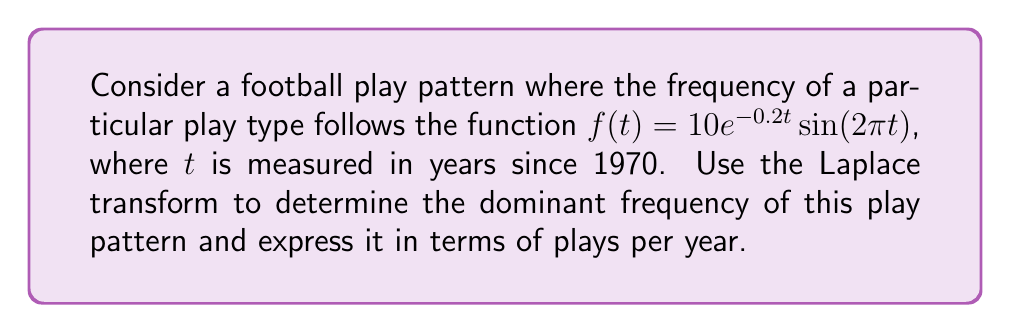Provide a solution to this math problem. To solve this problem, we'll follow these steps:

1) First, recall the Laplace transform of $f(t) = 10e^{-0.2t}\sin(2\pi t)$:

   $$\mathcal{L}\{10e^{-0.2t}\sin(2\pi t)\} = \frac{10(2\pi)}{(s+0.2)^2 + (2\pi)^2}$$

2) The dominant frequency of the play pattern corresponds to the imaginary part of the complex poles of this Laplace transform.

3) To find the poles, we set the denominator to zero:

   $$(s+0.2)^2 + (2\pi)^2 = 0$$

4) Solving this equation:

   $$s^2 + 0.4s + 0.04 + 4\pi^2 = 0$$
   
   $$s = -0.2 \pm i2\pi$$

5) The imaginary part of these poles is $\pm 2\pi$.

6) The frequency in radians per year is therefore $2\pi$.

7) To convert this to plays per year, we divide by $2\pi$:

   $$\frac{2\pi}{2\pi} = 1\text{ cycle/year}$$

Thus, the dominant frequency is 1 cycle per year.
Answer: The dominant frequency of the play pattern is 1 play per year. 